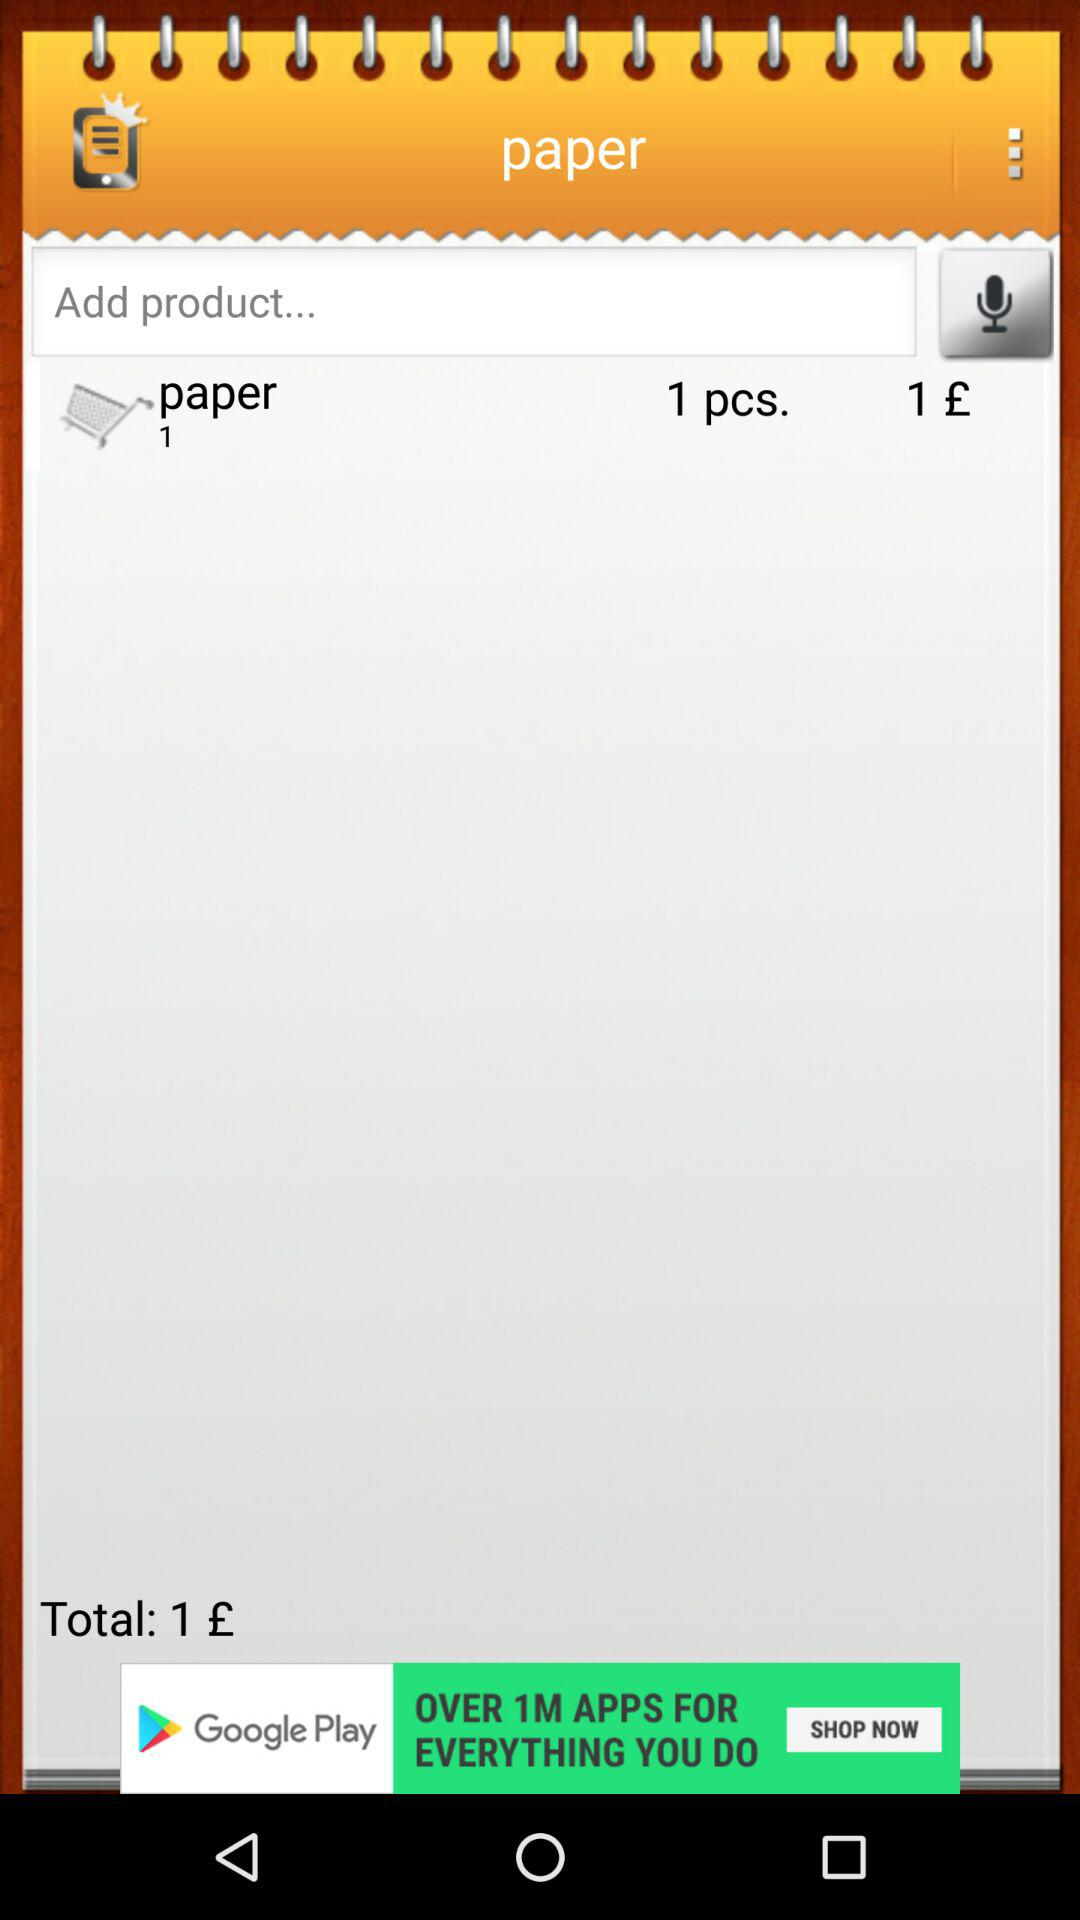What is the name of the application?
When the provided information is insufficient, respond with <no answer>. <no answer> 